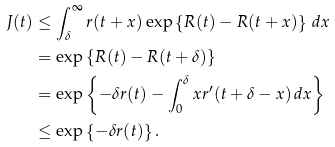<formula> <loc_0><loc_0><loc_500><loc_500>J ( t ) & \leq \int _ { \delta } ^ { \infty } r ( t + x ) \exp \left \{ R ( t ) - R ( t + x ) \right \} \, d x \\ & = \exp \left \{ R ( t ) - R ( t + \delta ) \right \} \\ & = \exp \left \{ - \delta r ( t ) - \int _ { 0 } ^ { \delta } x r ^ { \prime } ( t + \delta - x ) \, d x \right \} \\ & \leq \exp \left \{ - \delta r ( t ) \right \} .</formula> 